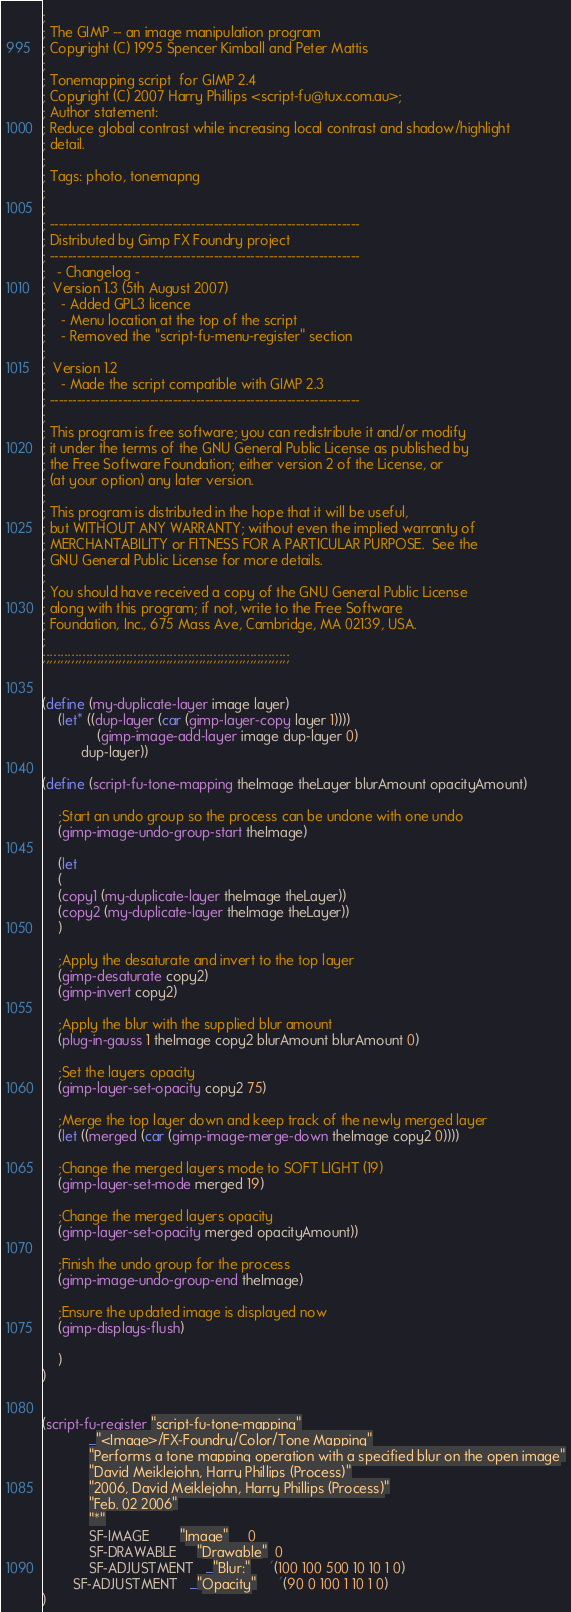Convert code to text. <code><loc_0><loc_0><loc_500><loc_500><_Scheme_>;
; The GIMP -- an image manipulation program
; Copyright (C) 1995 Spencer Kimball and Peter Mattis
;
; Tonemapping script  for GIMP 2.4
; Copyright (C) 2007 Harry Phillips <script-fu@tux.com.au>;
; Author statement:
; Reduce global contrast while increasing local contrast and shadow/highlight
; detail.
;
; Tags: photo, tonemapng
;
;
; --------------------------------------------------------------------
; Distributed by Gimp FX Foundry project
; --------------------------------------------------------------------
;   - Changelog -
;  Version 1.3 (5th August 2007)
;    - Added GPL3 licence
;    - Menu location at the top of the script
;    - Removed the "script-fu-menu-register" section
;
;  Version 1.2
;    - Made the script compatible with GIMP 2.3
; --------------------------------------------------------------------
;
; This program is free software; you can redistribute it and/or modify
; it under the terms of the GNU General Public License as published by
; the Free Software Foundation; either version 2 of the License, or
; (at your option) any later version.
;
; This program is distributed in the hope that it will be useful,
; but WITHOUT ANY WARRANTY; without even the implied warranty of
; MERCHANTABILITY or FITNESS FOR A PARTICULAR PURPOSE.  See the
; GNU General Public License for more details.
;
; You should have received a copy of the GNU General Public License
; along with this program; if not, write to the Free Software
; Foundation, Inc., 675 Mass Ave, Cambridge, MA 02139, USA.
;
;;;;;;;;;;;;;;;;;;;;;;;;;;;;;;;;;;;;;;;;;;;;;;;;;;;;;;;;;;;;;;;;;;;;


(define (my-duplicate-layer image layer)
    (let* ((dup-layer (car (gimp-layer-copy layer 1))))
              (gimp-image-add-layer image dup-layer 0)
          dup-layer))

(define (script-fu-tone-mapping theImage theLayer blurAmount opacityAmount)

    ;Start an undo group so the process can be undone with one undo
    (gimp-image-undo-group-start theImage)

    (let
    (
    (copy1 (my-duplicate-layer theImage theLayer))
    (copy2 (my-duplicate-layer theImage theLayer))
    )

    ;Apply the desaturate and invert to the top layer
    (gimp-desaturate copy2)
    (gimp-invert copy2)

    ;Apply the blur with the supplied blur amount
    (plug-in-gauss 1 theImage copy2 blurAmount blurAmount 0)

    ;Set the layers opacity
    (gimp-layer-set-opacity copy2 75)

    ;Merge the top layer down and keep track of the newly merged layer
    (let ((merged (car (gimp-image-merge-down theImage copy2 0))))

    ;Change the merged layers mode to SOFT LIGHT (19)
    (gimp-layer-set-mode merged 19)

    ;Change the merged layers opacity
    (gimp-layer-set-opacity merged opacityAmount))

    ;Finish the undo group for the process
    (gimp-image-undo-group-end theImage)

    ;Ensure the updated image is displayed now
    (gimp-displays-flush)

    )
)


(script-fu-register "script-fu-tone-mapping"
            _"<Image>/FX-Foundry/Color/Tone Mapping"
            "Performs a tone mapping operation with a specified blur on the open image"
            "David Meiklejohn, Harry Phillips (Process)"
            "2006, David Meiklejohn, Harry Phillips (Process)"
            "Feb. 02 2006"
            "*"
            SF-IMAGE        "Image"     0
            SF-DRAWABLE     "Drawable"  0
            SF-ADJUSTMENT   _"Blur:"     '(100 100 500 10 10 1 0)
        SF-ADJUSTMENT   _"Opacity"      '(90 0 100 1 10 1 0)
)

</code> 